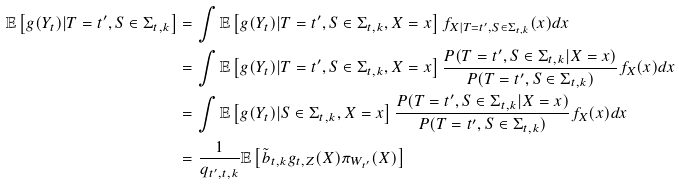<formula> <loc_0><loc_0><loc_500><loc_500>\mathbb { E } \left [ g ( Y _ { t } ) | T = t ^ { \prime } , S \in \Sigma _ { t , k } \right ] & = \int \mathbb { E } \left [ g ( Y _ { t } ) | T = t ^ { \prime } , S \in \Sigma _ { t , k } , X = x \right ] f _ { X | T = t ^ { \prime } , S \in \Sigma _ { t , k } } ( x ) d x \\ & = \int \mathbb { E } \left [ g ( Y _ { t } ) | T = t ^ { \prime } , S \in \Sigma _ { t , k } , X = x \right ] \frac { P ( T = t ^ { \prime } , S \in \Sigma _ { t , k } | X = x ) } { P ( T = t ^ { \prime } , S \in \Sigma _ { t , k } ) } f _ { X } ( x ) d x \\ & = \int \mathbb { E } \left [ g ( Y _ { t } ) | S \in \Sigma _ { t , k } , X = x \right ] \frac { P ( T = t ^ { \prime } , S \in \Sigma _ { t , k } | X = x ) } { P ( T = t ^ { \prime } , S \in \Sigma _ { t , k } ) } f _ { X } ( x ) d x \\ & = \frac { 1 } { q _ { t ^ { \prime } , t , k } } \mathbb { E } \left [ \tilde { b } _ { t , k } g _ { t , Z } ( X ) \pi _ { W _ { t ^ { \prime } } } ( X ) \right ]</formula> 